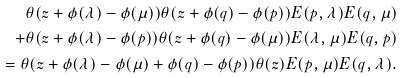<formula> <loc_0><loc_0><loc_500><loc_500>\theta ( z + \phi ( \lambda ) - \phi ( \mu ) ) \theta ( z + \phi ( q ) - \phi ( p ) ) E ( p , \lambda ) E ( q , \mu ) \\ + \theta ( z + \phi ( \lambda ) - \phi ( p ) ) \theta ( z + \phi ( q ) - \phi ( \mu ) ) E ( \lambda , \mu ) E ( q , p ) \\ = \theta ( z + \phi ( \lambda ) - \phi ( \mu ) + \phi ( q ) - \phi ( p ) ) \theta ( z ) E ( p , \mu ) E ( q , \lambda ) .</formula> 